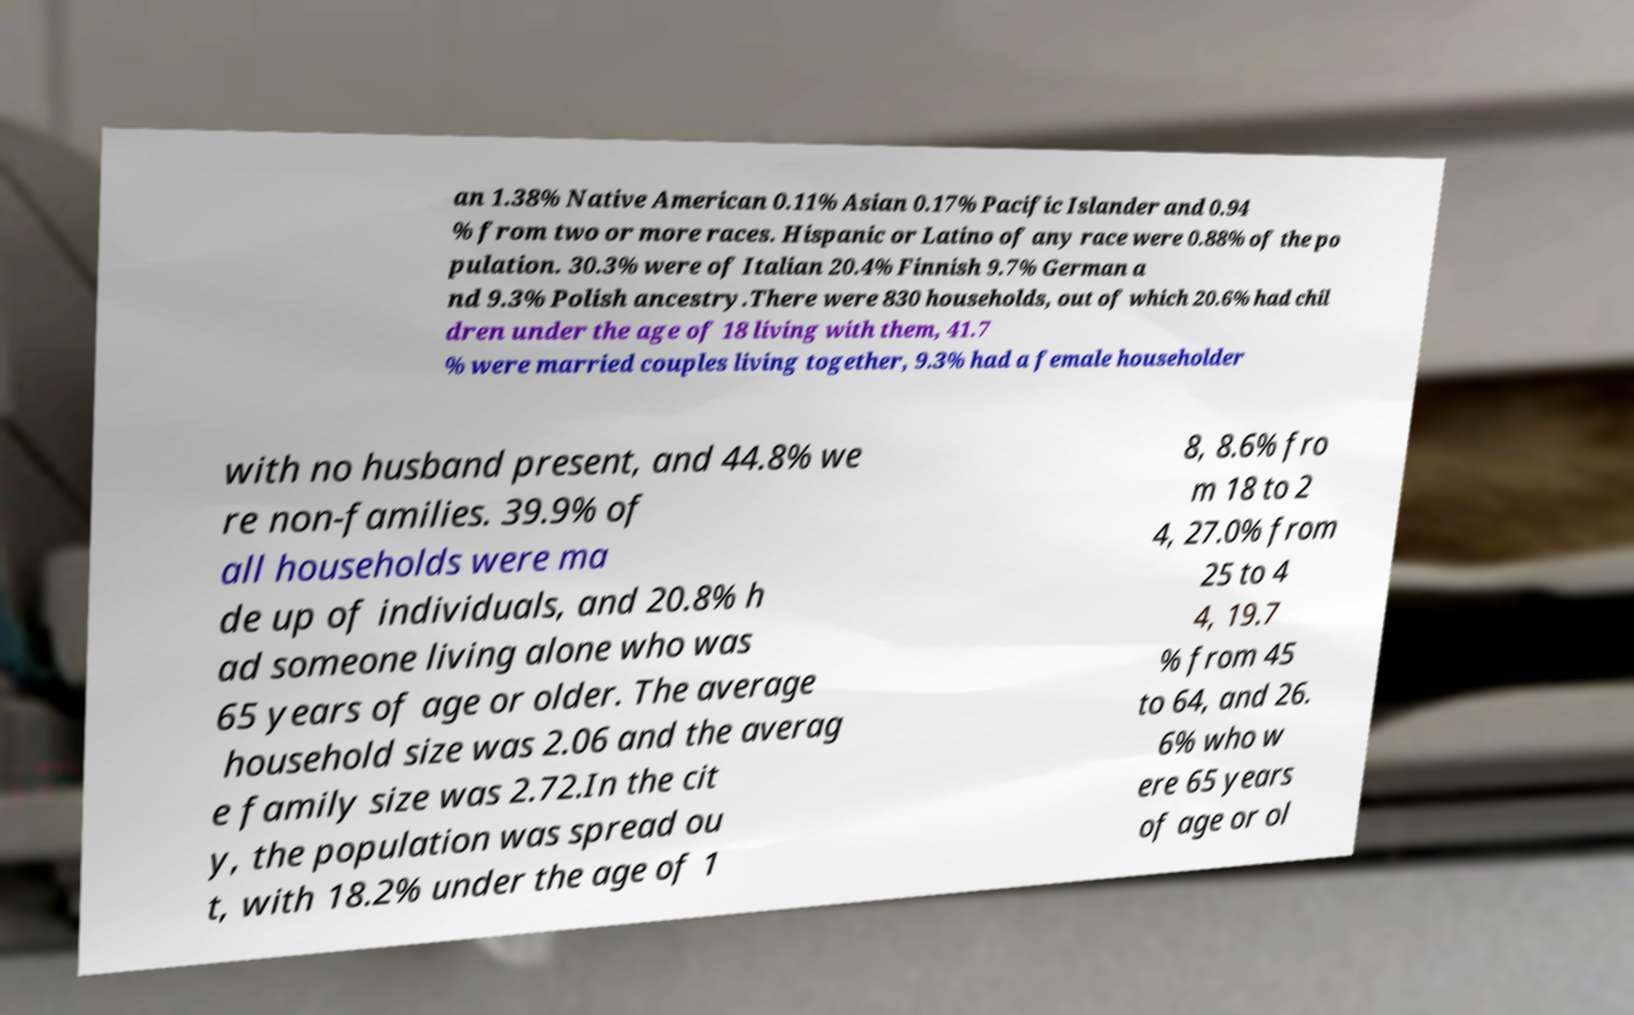Please identify and transcribe the text found in this image. an 1.38% Native American 0.11% Asian 0.17% Pacific Islander and 0.94 % from two or more races. Hispanic or Latino of any race were 0.88% of the po pulation. 30.3% were of Italian 20.4% Finnish 9.7% German a nd 9.3% Polish ancestry.There were 830 households, out of which 20.6% had chil dren under the age of 18 living with them, 41.7 % were married couples living together, 9.3% had a female householder with no husband present, and 44.8% we re non-families. 39.9% of all households were ma de up of individuals, and 20.8% h ad someone living alone who was 65 years of age or older. The average household size was 2.06 and the averag e family size was 2.72.In the cit y, the population was spread ou t, with 18.2% under the age of 1 8, 8.6% fro m 18 to 2 4, 27.0% from 25 to 4 4, 19.7 % from 45 to 64, and 26. 6% who w ere 65 years of age or ol 